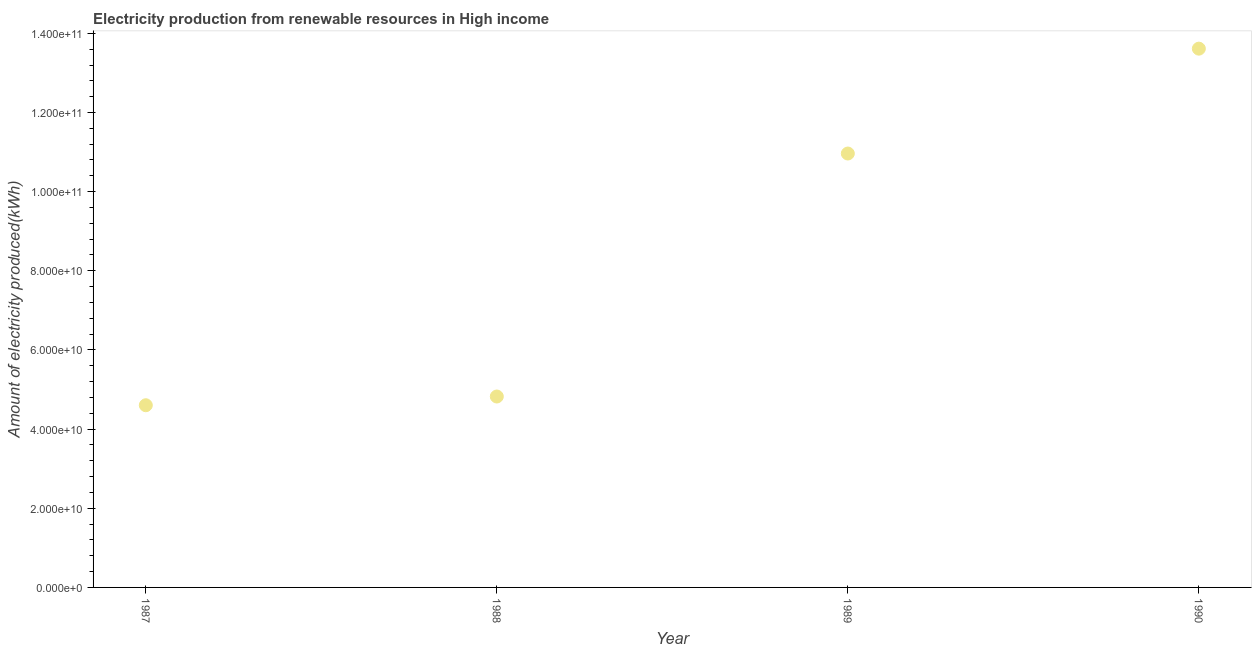What is the amount of electricity produced in 1990?
Offer a terse response. 1.36e+11. Across all years, what is the maximum amount of electricity produced?
Offer a very short reply. 1.36e+11. Across all years, what is the minimum amount of electricity produced?
Give a very brief answer. 4.60e+1. In which year was the amount of electricity produced maximum?
Provide a succinct answer. 1990. What is the sum of the amount of electricity produced?
Give a very brief answer. 3.40e+11. What is the difference between the amount of electricity produced in 1987 and 1988?
Your response must be concise. -2.20e+09. What is the average amount of electricity produced per year?
Offer a very short reply. 8.50e+1. What is the median amount of electricity produced?
Your response must be concise. 7.89e+1. In how many years, is the amount of electricity produced greater than 20000000000 kWh?
Your answer should be very brief. 4. What is the ratio of the amount of electricity produced in 1988 to that in 1989?
Make the answer very short. 0.44. Is the amount of electricity produced in 1988 less than that in 1989?
Offer a very short reply. Yes. What is the difference between the highest and the second highest amount of electricity produced?
Your answer should be compact. 2.65e+1. What is the difference between the highest and the lowest amount of electricity produced?
Your answer should be compact. 9.01e+1. In how many years, is the amount of electricity produced greater than the average amount of electricity produced taken over all years?
Your answer should be compact. 2. Does the amount of electricity produced monotonically increase over the years?
Offer a very short reply. Yes. Are the values on the major ticks of Y-axis written in scientific E-notation?
Make the answer very short. Yes. Does the graph contain grids?
Your answer should be very brief. No. What is the title of the graph?
Your answer should be compact. Electricity production from renewable resources in High income. What is the label or title of the X-axis?
Provide a short and direct response. Year. What is the label or title of the Y-axis?
Your answer should be very brief. Amount of electricity produced(kWh). What is the Amount of electricity produced(kWh) in 1987?
Offer a terse response. 4.60e+1. What is the Amount of electricity produced(kWh) in 1988?
Your answer should be very brief. 4.82e+1. What is the Amount of electricity produced(kWh) in 1989?
Offer a terse response. 1.10e+11. What is the Amount of electricity produced(kWh) in 1990?
Offer a terse response. 1.36e+11. What is the difference between the Amount of electricity produced(kWh) in 1987 and 1988?
Your response must be concise. -2.20e+09. What is the difference between the Amount of electricity produced(kWh) in 1987 and 1989?
Offer a terse response. -6.36e+1. What is the difference between the Amount of electricity produced(kWh) in 1987 and 1990?
Your answer should be very brief. -9.01e+1. What is the difference between the Amount of electricity produced(kWh) in 1988 and 1989?
Ensure brevity in your answer.  -6.14e+1. What is the difference between the Amount of electricity produced(kWh) in 1988 and 1990?
Your answer should be compact. -8.79e+1. What is the difference between the Amount of electricity produced(kWh) in 1989 and 1990?
Your answer should be very brief. -2.65e+1. What is the ratio of the Amount of electricity produced(kWh) in 1987 to that in 1988?
Keep it short and to the point. 0.95. What is the ratio of the Amount of electricity produced(kWh) in 1987 to that in 1989?
Ensure brevity in your answer.  0.42. What is the ratio of the Amount of electricity produced(kWh) in 1987 to that in 1990?
Offer a very short reply. 0.34. What is the ratio of the Amount of electricity produced(kWh) in 1988 to that in 1989?
Give a very brief answer. 0.44. What is the ratio of the Amount of electricity produced(kWh) in 1988 to that in 1990?
Ensure brevity in your answer.  0.35. What is the ratio of the Amount of electricity produced(kWh) in 1989 to that in 1990?
Your answer should be compact. 0.81. 